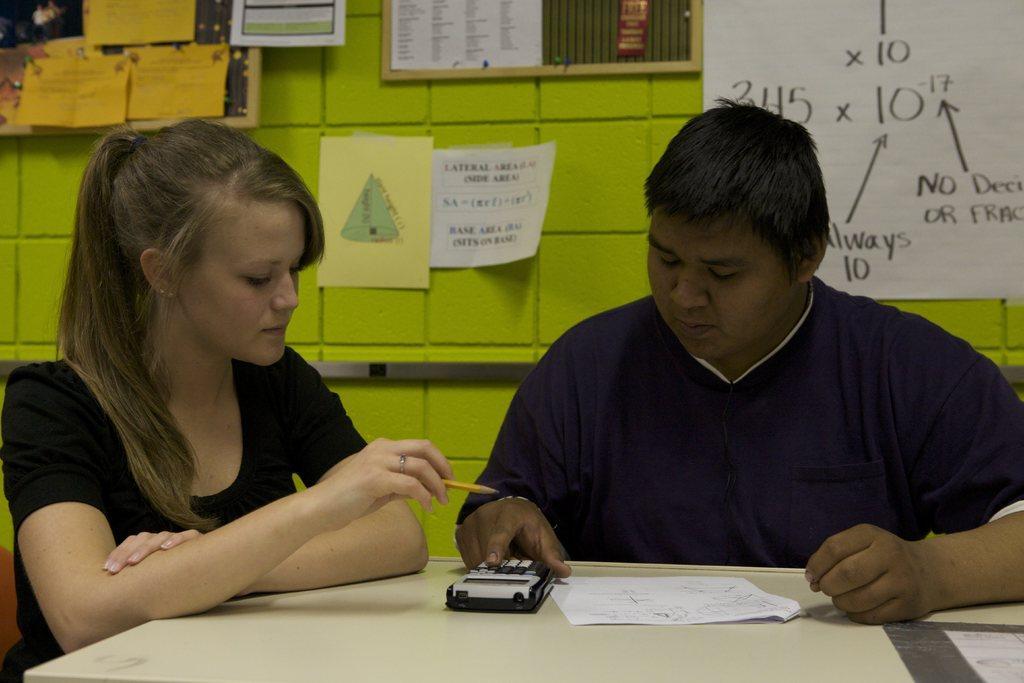Could you give a brief overview of what you see in this image? In the picture I can see a man on the right side is wearing a T-shirt and he is operating a calculator. There is a woman on the left side and she is holding a pencil in her hand. I can see the table at the bottom of the picture. In the background, I can see the cardboards on the wall. 